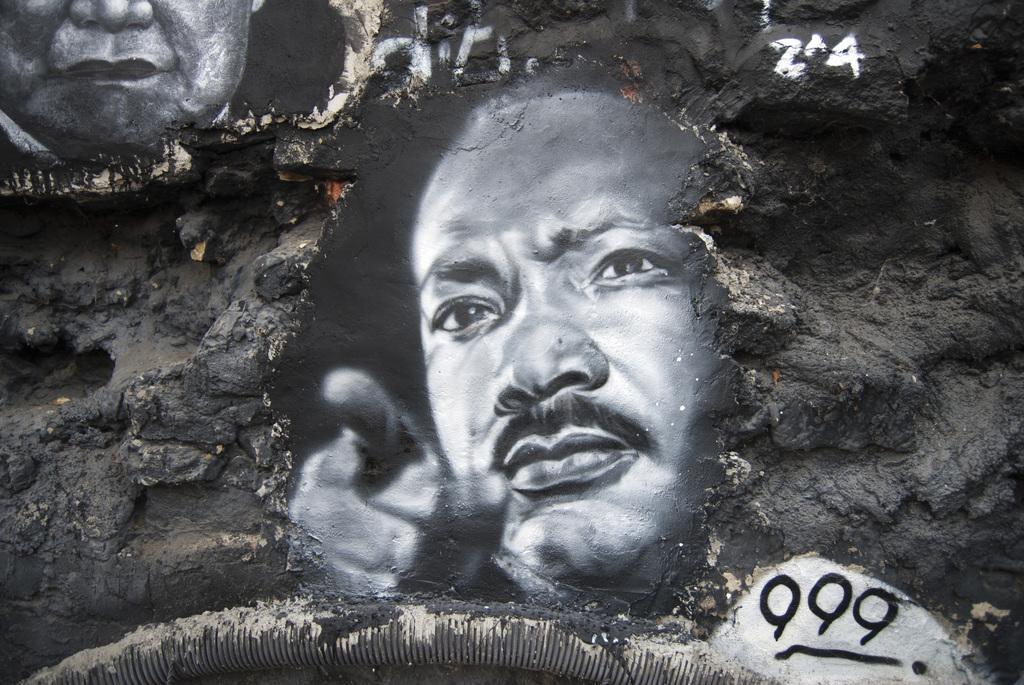Could you give a brief overview of what you see in this image? In this image, I can see the painting of two people's faces on the rock. This looks like a pipe, which is attached to the rock. 